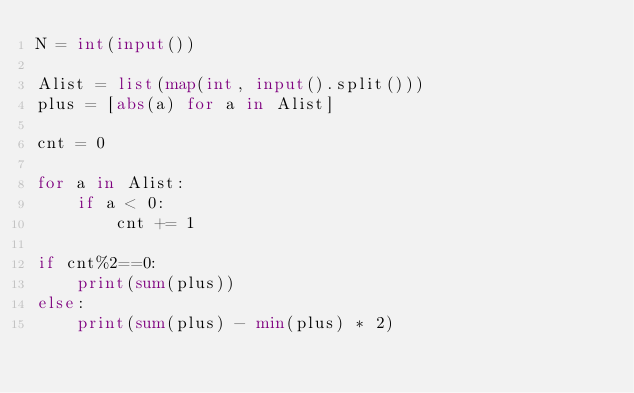<code> <loc_0><loc_0><loc_500><loc_500><_Python_>N = int(input())

Alist = list(map(int, input().split()))
plus = [abs(a) for a in Alist]

cnt = 0

for a in Alist:
    if a < 0:
        cnt += 1

if cnt%2==0:
    print(sum(plus))
else:
    print(sum(plus) - min(plus) * 2)</code> 